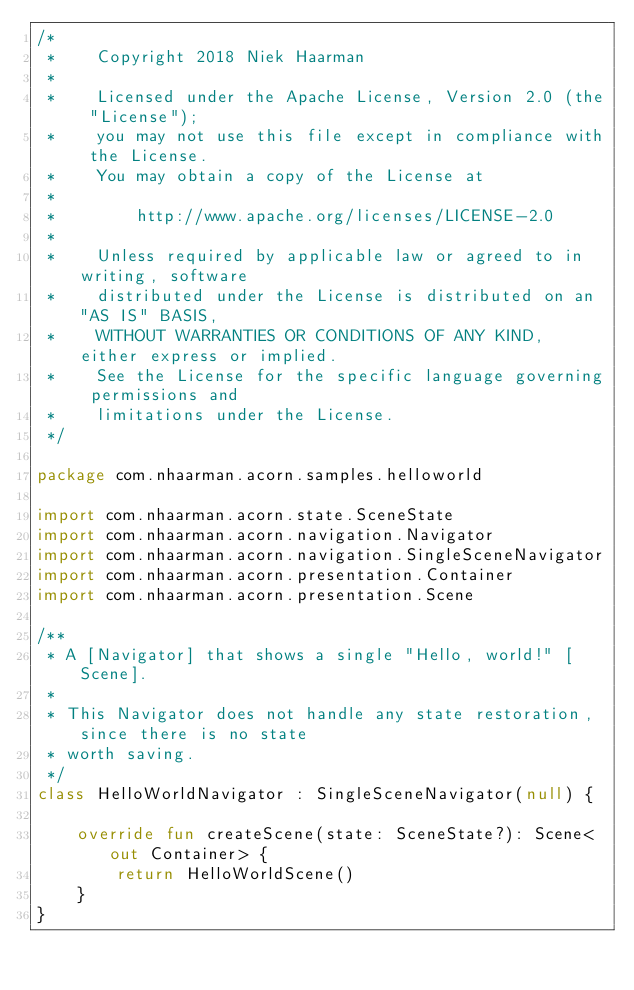Convert code to text. <code><loc_0><loc_0><loc_500><loc_500><_Kotlin_>/*
 *    Copyright 2018 Niek Haarman
 *
 *    Licensed under the Apache License, Version 2.0 (the "License");
 *    you may not use this file except in compliance with the License.
 *    You may obtain a copy of the License at
 *
 *        http://www.apache.org/licenses/LICENSE-2.0
 *
 *    Unless required by applicable law or agreed to in writing, software
 *    distributed under the License is distributed on an "AS IS" BASIS,
 *    WITHOUT WARRANTIES OR CONDITIONS OF ANY KIND, either express or implied.
 *    See the License for the specific language governing permissions and
 *    limitations under the License.
 */

package com.nhaarman.acorn.samples.helloworld

import com.nhaarman.acorn.state.SceneState
import com.nhaarman.acorn.navigation.Navigator
import com.nhaarman.acorn.navigation.SingleSceneNavigator
import com.nhaarman.acorn.presentation.Container
import com.nhaarman.acorn.presentation.Scene

/**
 * A [Navigator] that shows a single "Hello, world!" [Scene].
 *
 * This Navigator does not handle any state restoration, since there is no state
 * worth saving.
 */
class HelloWorldNavigator : SingleSceneNavigator(null) {

    override fun createScene(state: SceneState?): Scene<out Container> {
        return HelloWorldScene()
    }
}</code> 